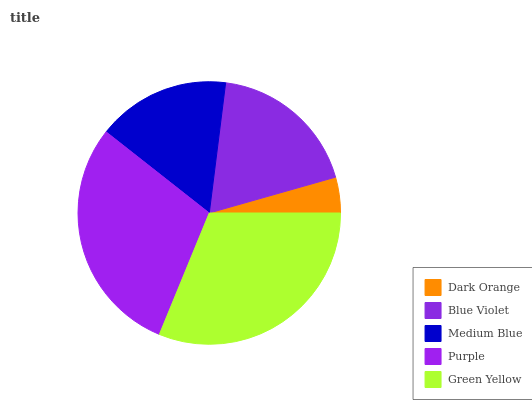Is Dark Orange the minimum?
Answer yes or no. Yes. Is Green Yellow the maximum?
Answer yes or no. Yes. Is Blue Violet the minimum?
Answer yes or no. No. Is Blue Violet the maximum?
Answer yes or no. No. Is Blue Violet greater than Dark Orange?
Answer yes or no. Yes. Is Dark Orange less than Blue Violet?
Answer yes or no. Yes. Is Dark Orange greater than Blue Violet?
Answer yes or no. No. Is Blue Violet less than Dark Orange?
Answer yes or no. No. Is Blue Violet the high median?
Answer yes or no. Yes. Is Blue Violet the low median?
Answer yes or no. Yes. Is Dark Orange the high median?
Answer yes or no. No. Is Green Yellow the low median?
Answer yes or no. No. 